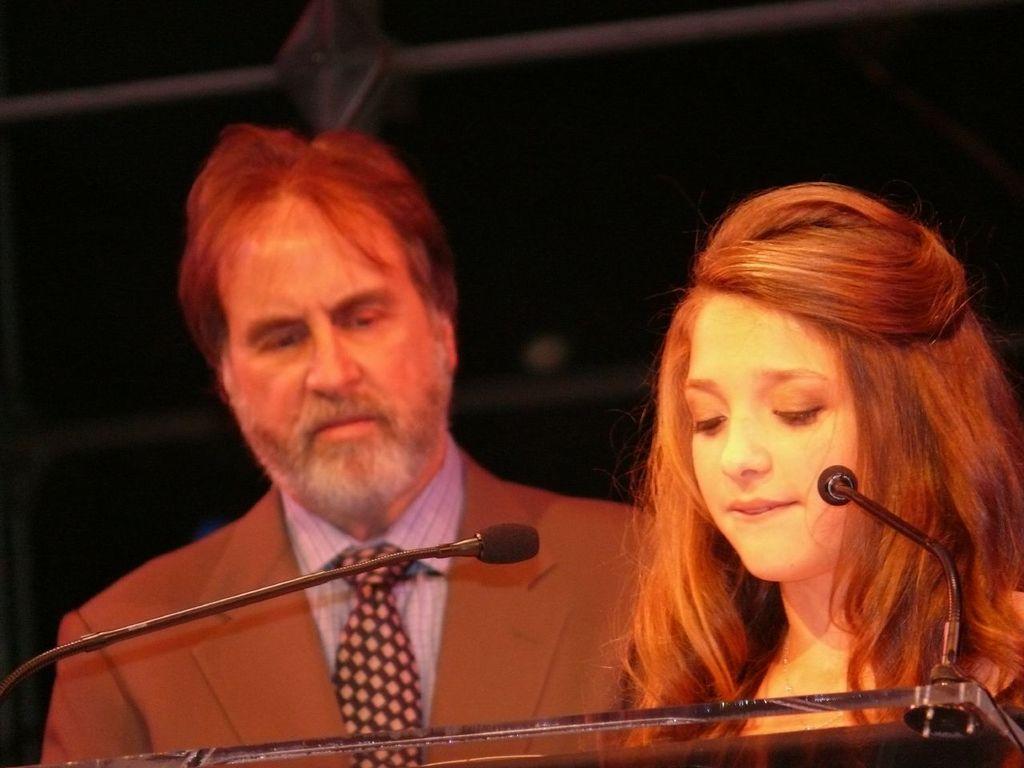Describe this image in one or two sentences. In the center of the image we can see two persons standing at the desk. In the background we can see a wall. 